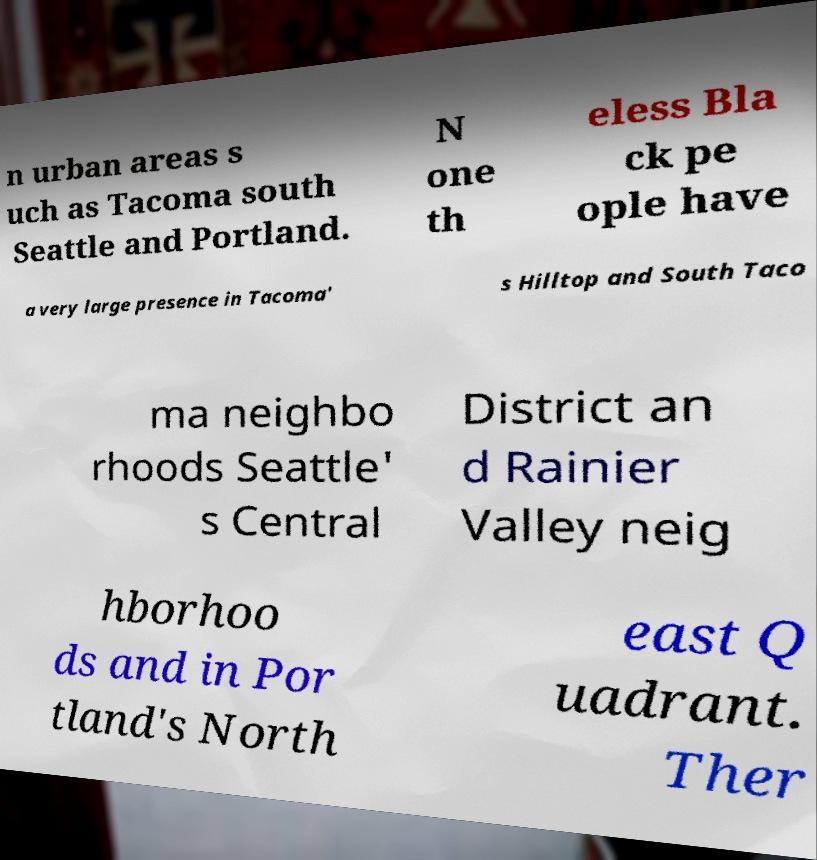Could you extract and type out the text from this image? n urban areas s uch as Tacoma south Seattle and Portland. N one th eless Bla ck pe ople have a very large presence in Tacoma' s Hilltop and South Taco ma neighbo rhoods Seattle' s Central District an d Rainier Valley neig hborhoo ds and in Por tland's North east Q uadrant. Ther 